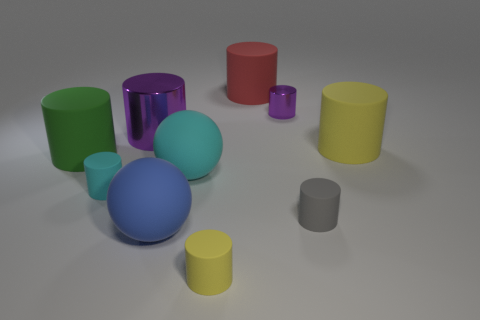Does the tiny purple shiny object have the same shape as the matte thing behind the tiny purple metal cylinder?
Your answer should be very brief. Yes. What is the size of the sphere that is in front of the small gray rubber object that is in front of the big red rubber cylinder?
Your answer should be compact. Large. Are there the same number of large red matte cylinders in front of the big green rubber cylinder and small gray cylinders behind the red matte cylinder?
Ensure brevity in your answer.  Yes. What color is the other metal object that is the same shape as the tiny metal object?
Provide a succinct answer. Purple. What number of large balls have the same color as the small shiny cylinder?
Keep it short and to the point. 0. There is a purple thing that is to the left of the large red matte cylinder; does it have the same shape as the large yellow matte object?
Provide a short and direct response. Yes. What shape is the small matte thing that is to the left of the yellow rubber object in front of the large matte cylinder left of the tiny cyan object?
Offer a very short reply. Cylinder. What is the size of the blue thing?
Ensure brevity in your answer.  Large. What is the color of the other large sphere that is made of the same material as the large blue sphere?
Your answer should be very brief. Cyan. What number of large red cylinders are made of the same material as the big green thing?
Your response must be concise. 1. 